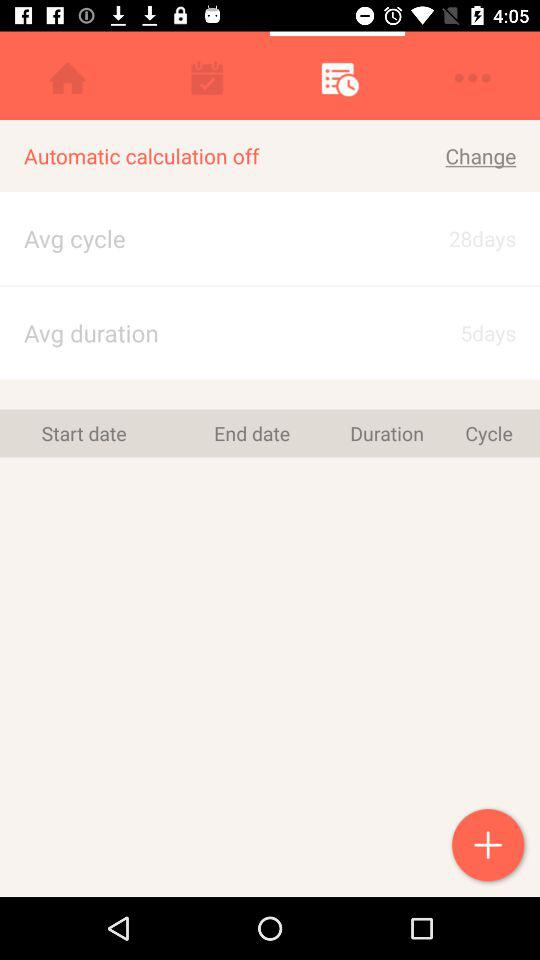What is the "Avg duration"? The "Avg duration" is 5 days. 